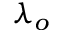Convert formula to latex. <formula><loc_0><loc_0><loc_500><loc_500>\lambda _ { o }</formula> 